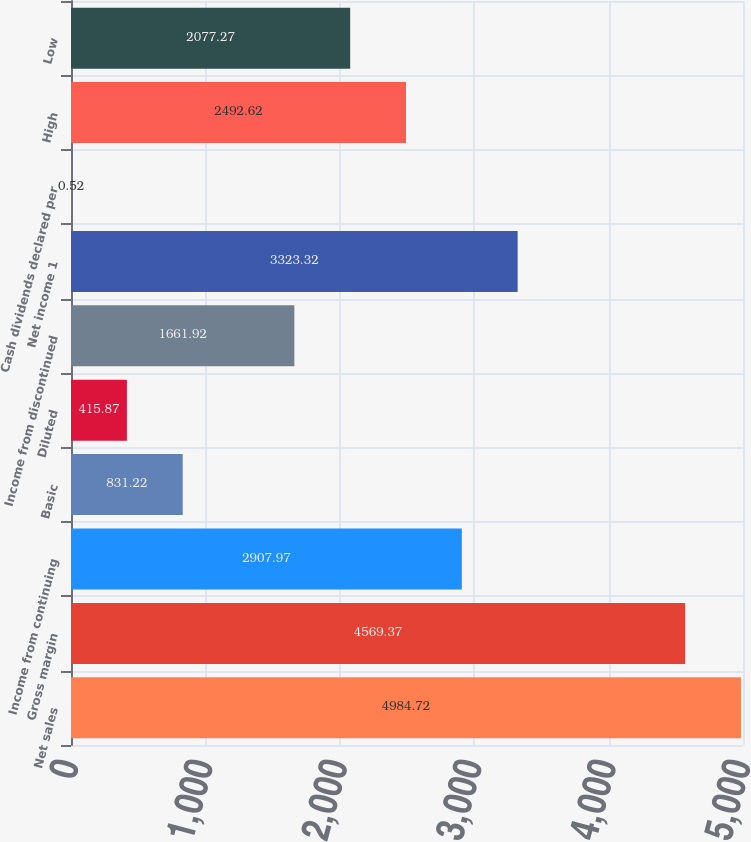<chart> <loc_0><loc_0><loc_500><loc_500><bar_chart><fcel>Net sales<fcel>Gross margin<fcel>Income from continuing<fcel>Basic<fcel>Diluted<fcel>Income from discontinued<fcel>Net income 1<fcel>Cash dividends declared per<fcel>High<fcel>Low<nl><fcel>4984.72<fcel>4569.37<fcel>2907.97<fcel>831.22<fcel>415.87<fcel>1661.92<fcel>3323.32<fcel>0.52<fcel>2492.62<fcel>2077.27<nl></chart> 